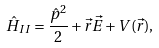<formula> <loc_0><loc_0><loc_500><loc_500>\hat { H } _ { I I } = \frac { \hat { p } ^ { 2 } } { 2 } + \vec { r } \vec { E } + V ( \vec { r } ) ,</formula> 